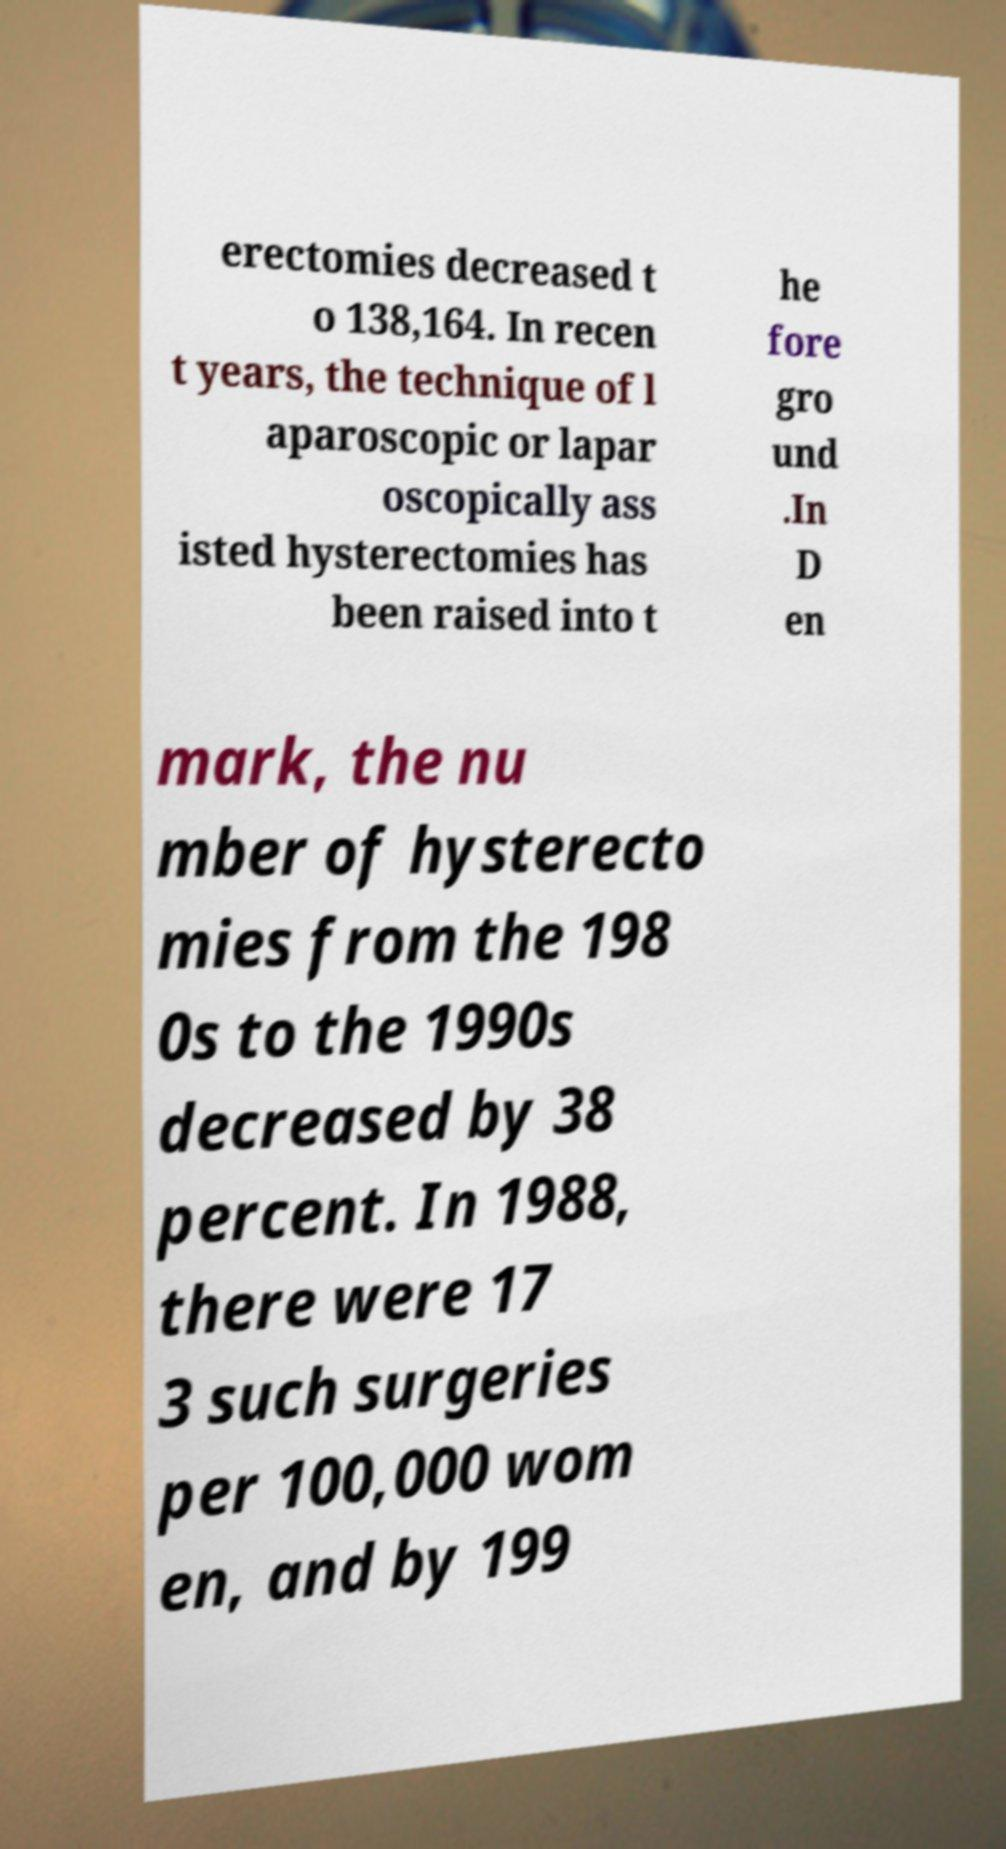What messages or text are displayed in this image? I need them in a readable, typed format. erectomies decreased t o 138,164. In recen t years, the technique of l aparoscopic or lapar oscopically ass isted hysterectomies has been raised into t he fore gro und .In D en mark, the nu mber of hysterecto mies from the 198 0s to the 1990s decreased by 38 percent. In 1988, there were 17 3 such surgeries per 100,000 wom en, and by 199 